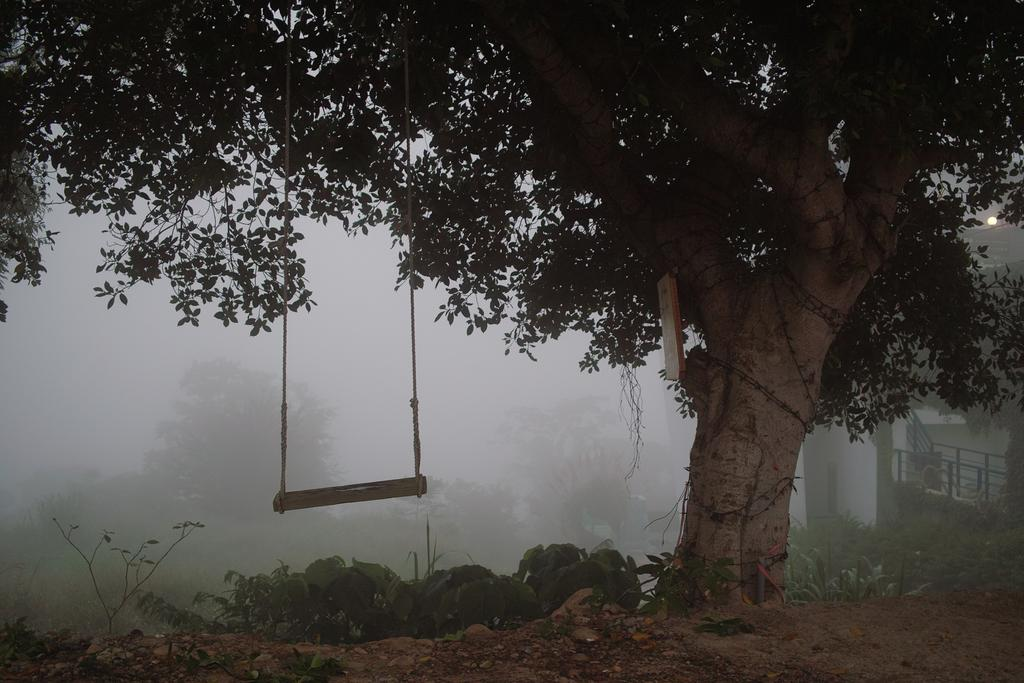What object is featured prominently in the image? There is a cradle in the image. How is the cradle secured in the image? The cradle is tied to a tree branch. What can be seen behind the tree in the image? There is a building behind the tree. What type of natural environment is visible in the background of the image? There are trees visible in the background of the image. What type of reward is hanging from the tree branch in the image? There is no reward hanging from the tree branch in the image; it is the cradle that is tied to the tree branch. How many snakes are coiled around the tree branch in the image? There are no snakes present in the image; the cradle is tied to the tree branch. 